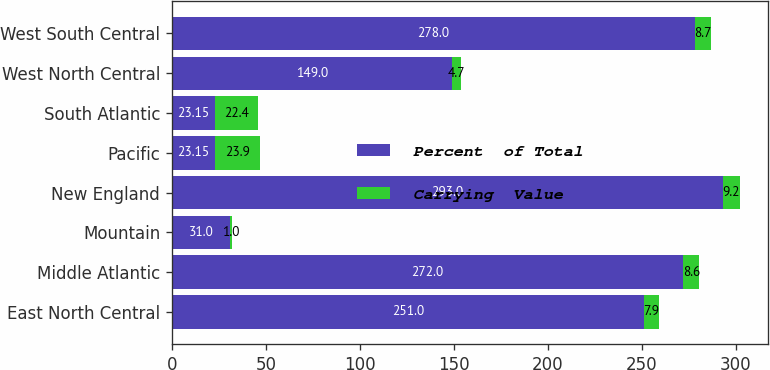Convert chart to OTSL. <chart><loc_0><loc_0><loc_500><loc_500><stacked_bar_chart><ecel><fcel>East North Central<fcel>Middle Atlantic<fcel>Mountain<fcel>New England<fcel>Pacific<fcel>South Atlantic<fcel>West North Central<fcel>West South Central<nl><fcel>Percent  of Total<fcel>251<fcel>272<fcel>31<fcel>293<fcel>23.15<fcel>23.15<fcel>149<fcel>278<nl><fcel>Carrying  Value<fcel>7.9<fcel>8.6<fcel>1<fcel>9.2<fcel>23.9<fcel>22.4<fcel>4.7<fcel>8.7<nl></chart> 